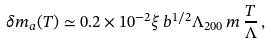<formula> <loc_0><loc_0><loc_500><loc_500>\delta m _ { a } ( T ) \simeq 0 . 2 \times 1 0 ^ { - 2 } \xi \, b ^ { 1 / 2 } \Lambda _ { 2 0 0 } \, m \, \frac { T } { \Lambda } \, ,</formula> 